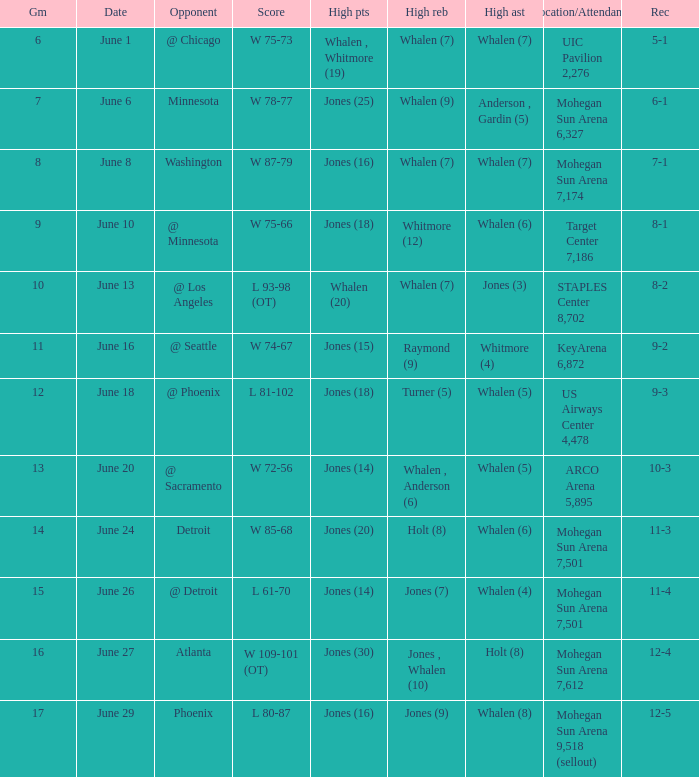Who had the high assists when the game was less than 13 and the score was w 75-66? Whalen (6). 